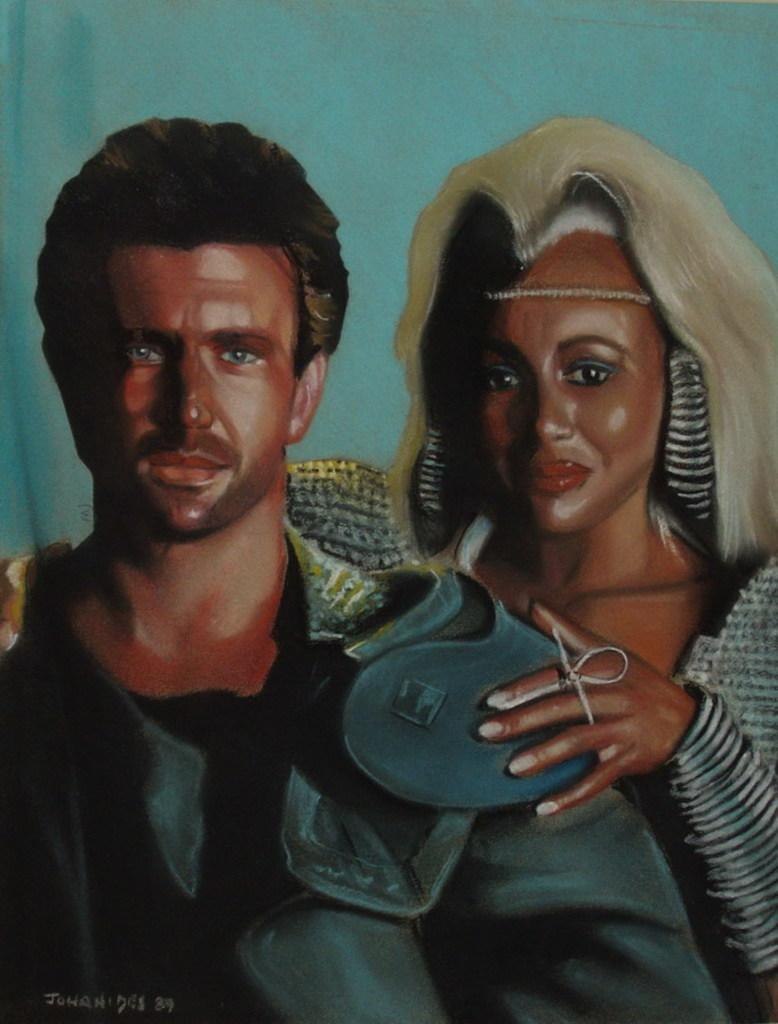What is the main subject of the image? The main subject of the image is a painting. What is depicted in the painting? The painting depicts two people. Are there any additional elements in the painting? Yes, there is writing on the painting. What type of voice can be heard coming from the painting? There is no voice present in the painting, as it is a visual medium and does not contain sound. 